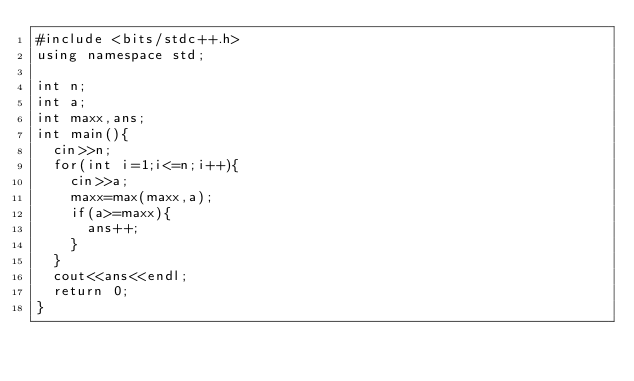Convert code to text. <code><loc_0><loc_0><loc_500><loc_500><_C++_>#include <bits/stdc++.h>
using namespace std;

int n;
int a;
int maxx,ans;
int main(){
	cin>>n;
	for(int i=1;i<=n;i++){
		cin>>a;
		maxx=max(maxx,a);
		if(a>=maxx){
			ans++;
		}
	}
	cout<<ans<<endl;
	return 0;
}</code> 